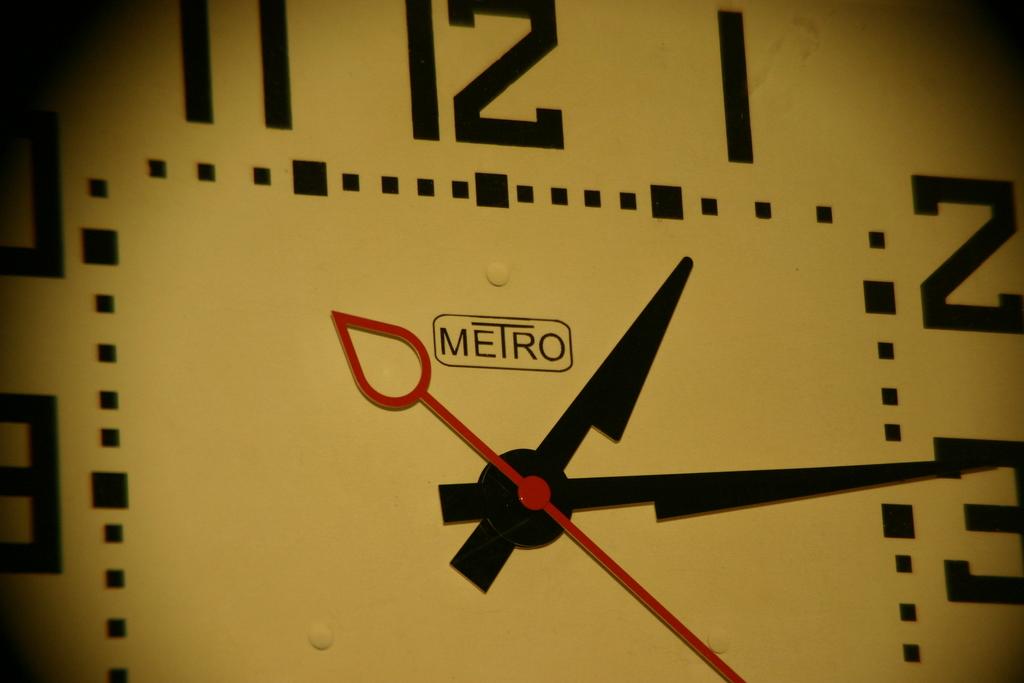What time does the clock say?
Offer a very short reply. 1:14. What brand is the clock?
Offer a very short reply. Metro. 